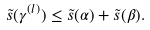<formula> <loc_0><loc_0><loc_500><loc_500>\tilde { s } ( \gamma ^ { ( l ) } ) \leq \tilde { s } ( \alpha ) + \tilde { s } ( \beta ) .</formula> 